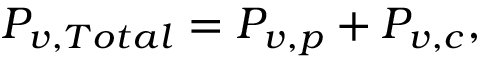Convert formula to latex. <formula><loc_0><loc_0><loc_500><loc_500>P _ { v , T o t a l } = P _ { v , p } + P _ { v , c } ,</formula> 